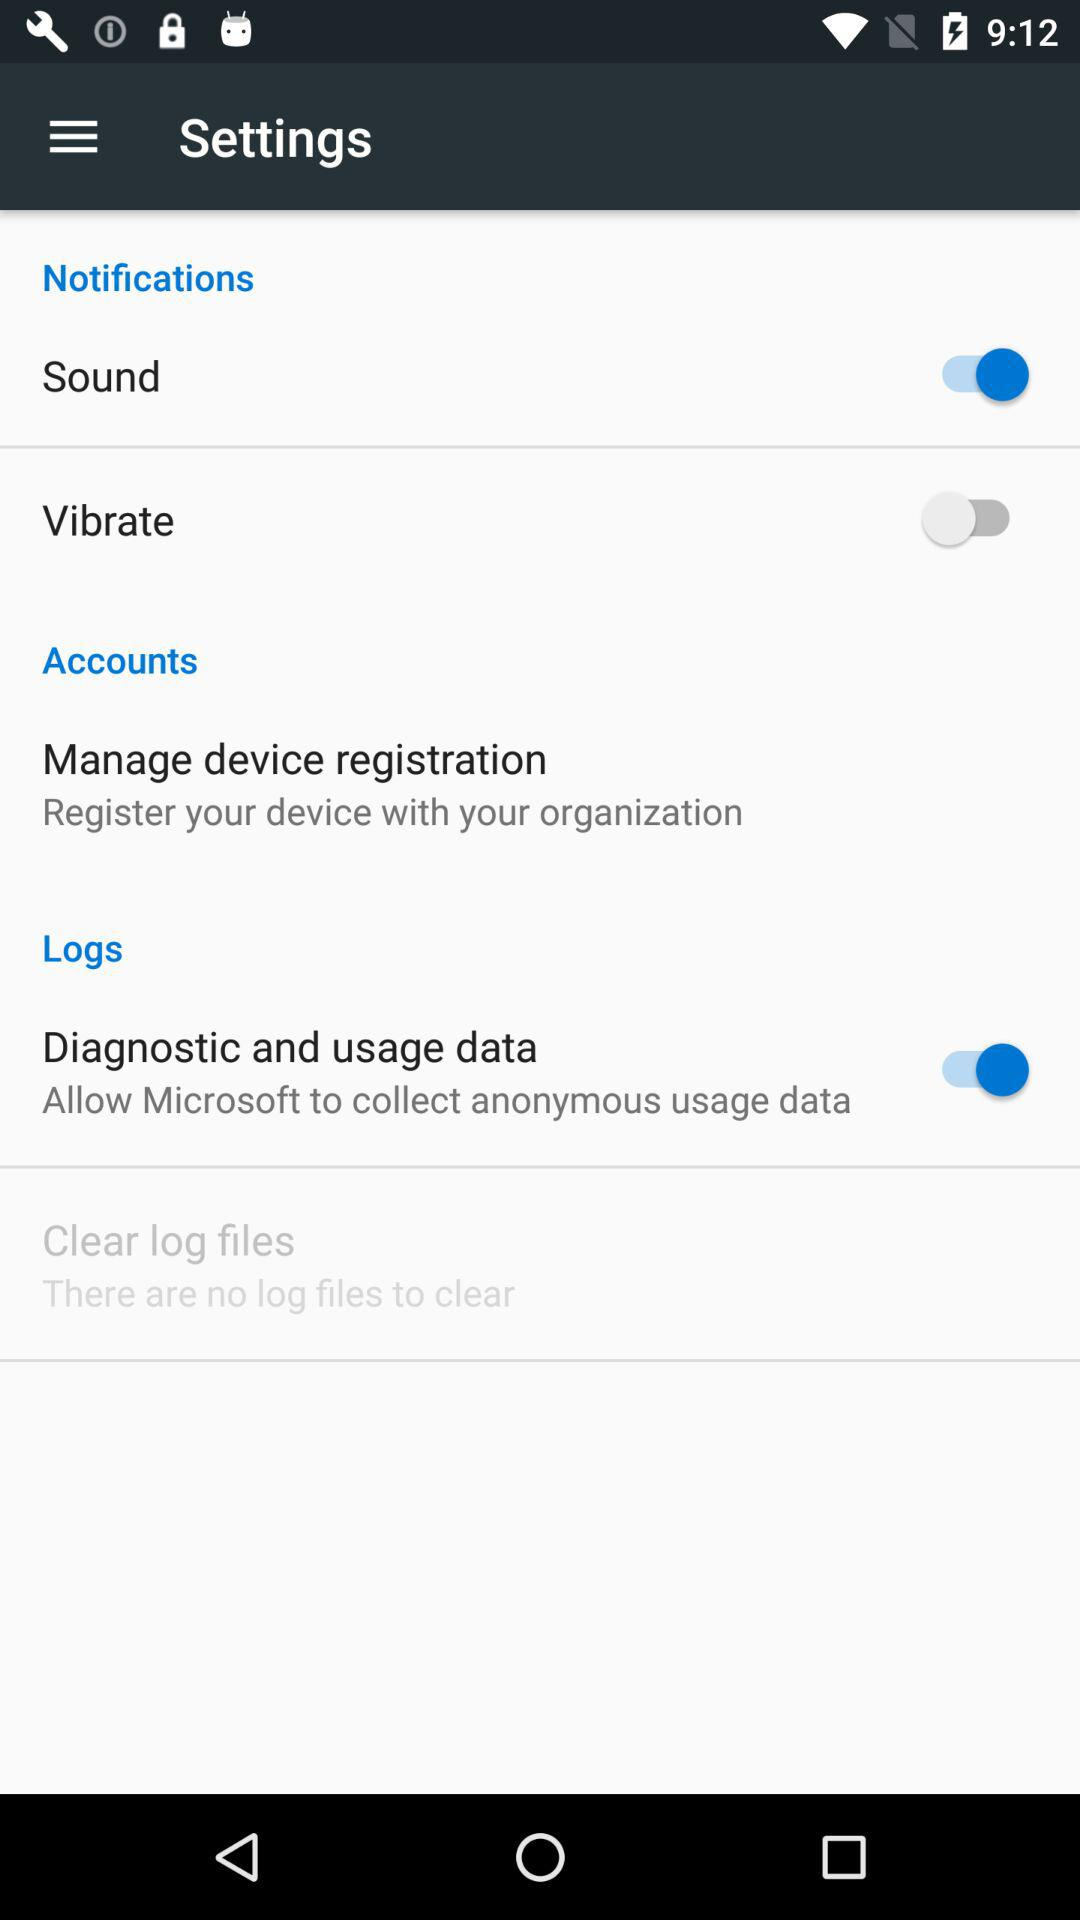What is the status of "Diagnostic and usage data"? The status is "on". 